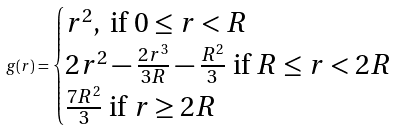Convert formula to latex. <formula><loc_0><loc_0><loc_500><loc_500>g ( r ) = \begin{cases} r ^ { 2 } , \text { if } 0 \leq r < R \\ 2 r ^ { 2 } - \frac { 2 r ^ { 3 } } { 3 R } - \frac { R ^ { 2 } } { 3 } \text { if } R \leq r < 2 R \\ \frac { 7 R ^ { 2 } } { 3 } \text { if } r \geq 2 R \end{cases}</formula> 